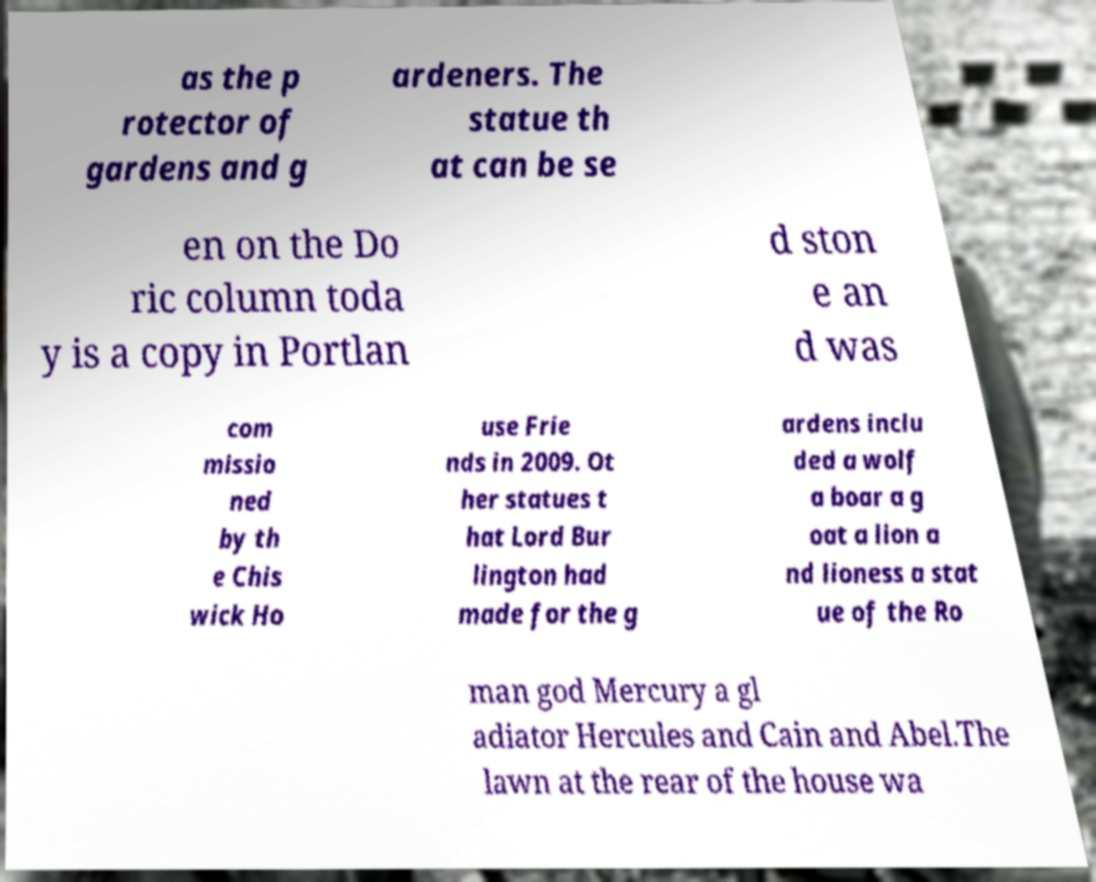Can you accurately transcribe the text from the provided image for me? as the p rotector of gardens and g ardeners. The statue th at can be se en on the Do ric column toda y is a copy in Portlan d ston e an d was com missio ned by th e Chis wick Ho use Frie nds in 2009. Ot her statues t hat Lord Bur lington had made for the g ardens inclu ded a wolf a boar a g oat a lion a nd lioness a stat ue of the Ro man god Mercury a gl adiator Hercules and Cain and Abel.The lawn at the rear of the house wa 